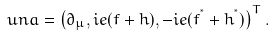Convert formula to latex. <formula><loc_0><loc_0><loc_500><loc_500>\ u n a = \left ( \partial _ { \mu } , i e ( f + h ) , - i e ( f ^ { ^ { * } } + h ^ { ^ { * } } ) \right ) ^ { T } .</formula> 